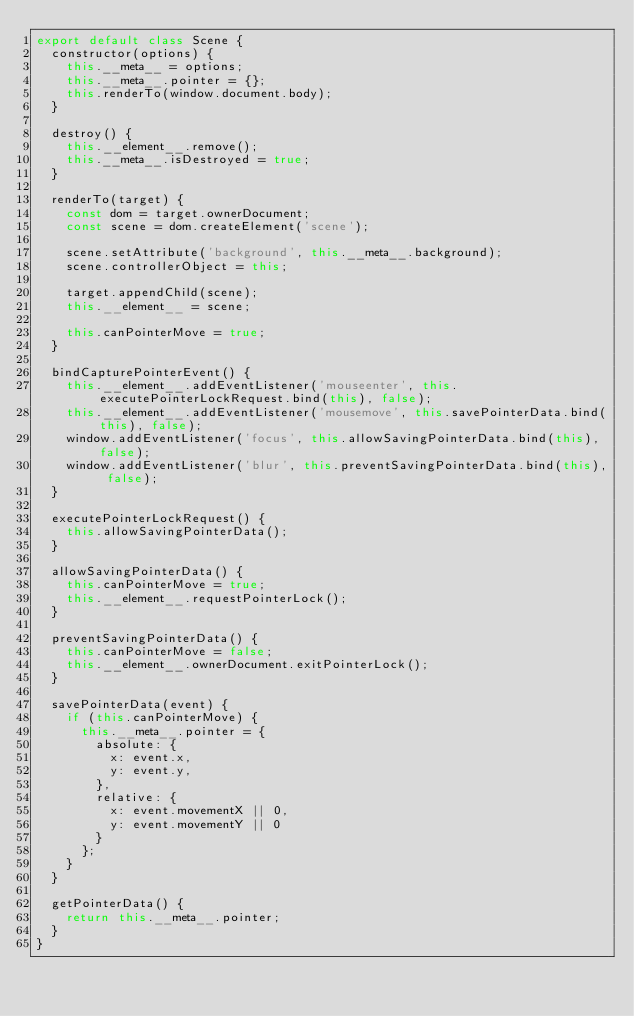Convert code to text. <code><loc_0><loc_0><loc_500><loc_500><_JavaScript_>export default class Scene {
  constructor(options) {
    this.__meta__ = options;
    this.__meta__.pointer = {};
    this.renderTo(window.document.body);
  }

  destroy() {
    this.__element__.remove();
    this.__meta__.isDestroyed = true;
  }

  renderTo(target) {
    const dom = target.ownerDocument;
    const scene = dom.createElement('scene');

    scene.setAttribute('background', this.__meta__.background);
    scene.controllerObject = this;

    target.appendChild(scene);
    this.__element__ = scene;

    this.canPointerMove = true;
  }

  bindCapturePointerEvent() {
    this.__element__.addEventListener('mouseenter', this.executePointerLockRequest.bind(this), false);
    this.__element__.addEventListener('mousemove', this.savePointerData.bind(this), false);
    window.addEventListener('focus', this.allowSavingPointerData.bind(this), false);
    window.addEventListener('blur', this.preventSavingPointerData.bind(this), false);
  }

  executePointerLockRequest() {
    this.allowSavingPointerData();
  }

  allowSavingPointerData() {
    this.canPointerMove = true;
    this.__element__.requestPointerLock();
  }

  preventSavingPointerData() {
    this.canPointerMove = false;
    this.__element__.ownerDocument.exitPointerLock();
  }

  savePointerData(event) {
    if (this.canPointerMove) {
      this.__meta__.pointer = {
        absolute: {
          x: event.x,
          y: event.y,
        },
        relative: {
          x: event.movementX || 0,
          y: event.movementY || 0
        }
      };
    }
  }

  getPointerData() {
    return this.__meta__.pointer;
  }
}
</code> 